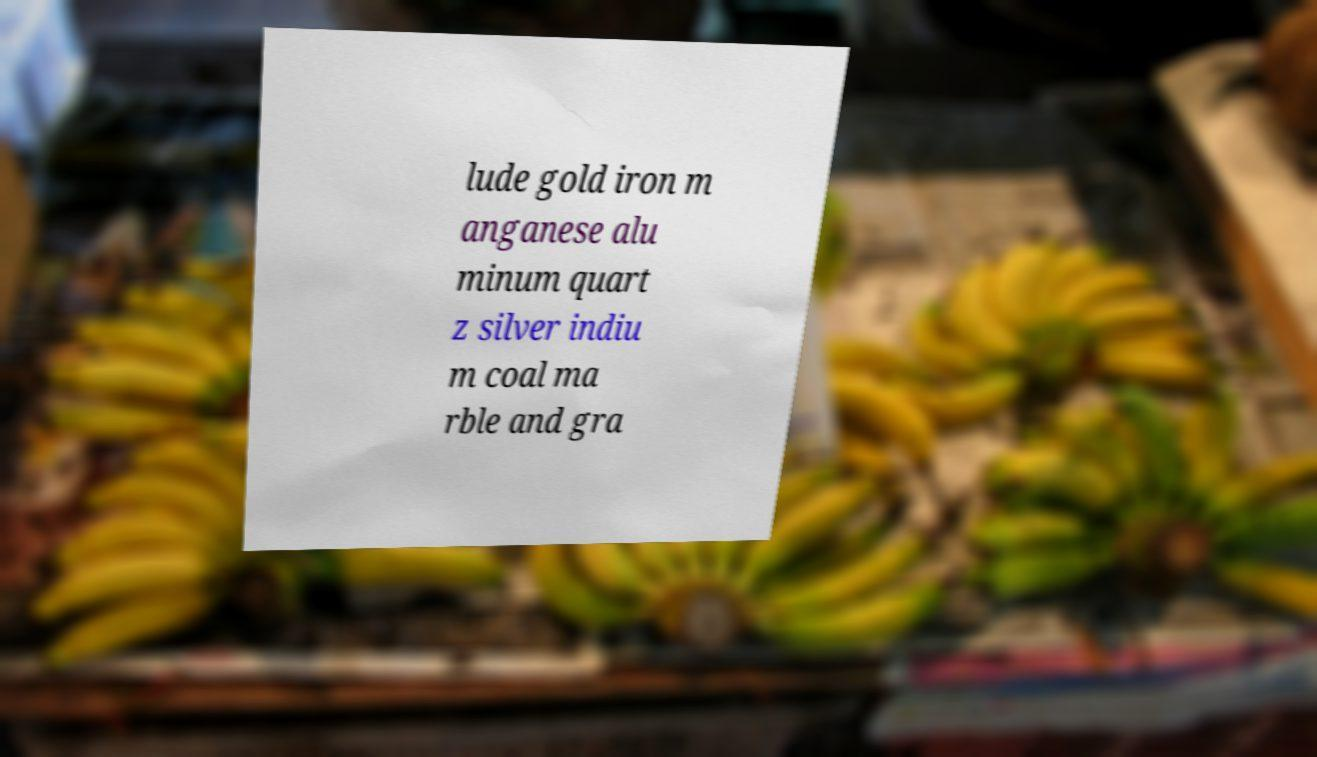What messages or text are displayed in this image? I need them in a readable, typed format. lude gold iron m anganese alu minum quart z silver indiu m coal ma rble and gra 